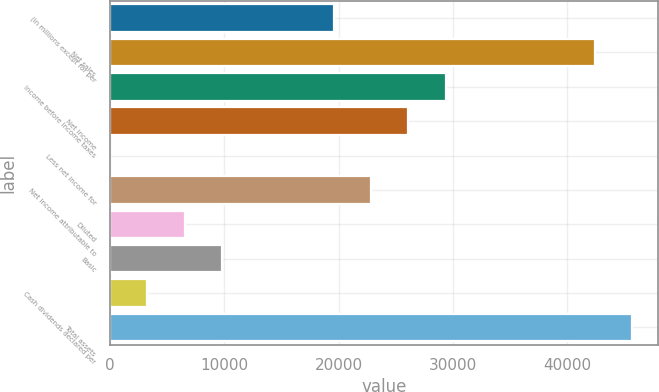Convert chart. <chart><loc_0><loc_0><loc_500><loc_500><bar_chart><fcel>(In millions except for per<fcel>Net sales<fcel>Income before income taxes<fcel>Net income<fcel>Less net income for<fcel>Net income attributable to<fcel>Diluted<fcel>Basic<fcel>Cash dividends declared per<fcel>Total assets<nl><fcel>19574.2<fcel>42409.6<fcel>29360.8<fcel>26098.6<fcel>1<fcel>22836.4<fcel>6525.4<fcel>9787.6<fcel>3263.2<fcel>45671.8<nl></chart> 